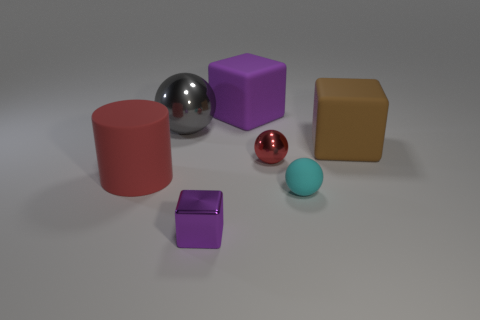There is a red object that is on the right side of the thing that is behind the big metal object; what is its shape?
Make the answer very short. Sphere. How many other things are there of the same material as the cyan thing?
Give a very brief answer. 3. Are there any other things that have the same size as the cyan thing?
Make the answer very short. Yes. Are there more matte blocks than large blue blocks?
Offer a terse response. Yes. There is a metallic thing that is in front of the tiny thing behind the large rubber object on the left side of the tiny block; what is its size?
Keep it short and to the point. Small. There is a metal cube; does it have the same size as the purple block that is behind the cyan thing?
Your response must be concise. No. Is the number of purple things that are behind the tiny shiny sphere less than the number of tiny cyan matte balls?
Provide a succinct answer. No. What number of shiny spheres are the same color as the matte cylinder?
Offer a terse response. 1. Is the number of large red rubber objects less than the number of big green rubber balls?
Give a very brief answer. No. Does the big purple block have the same material as the gray object?
Provide a succinct answer. No. 